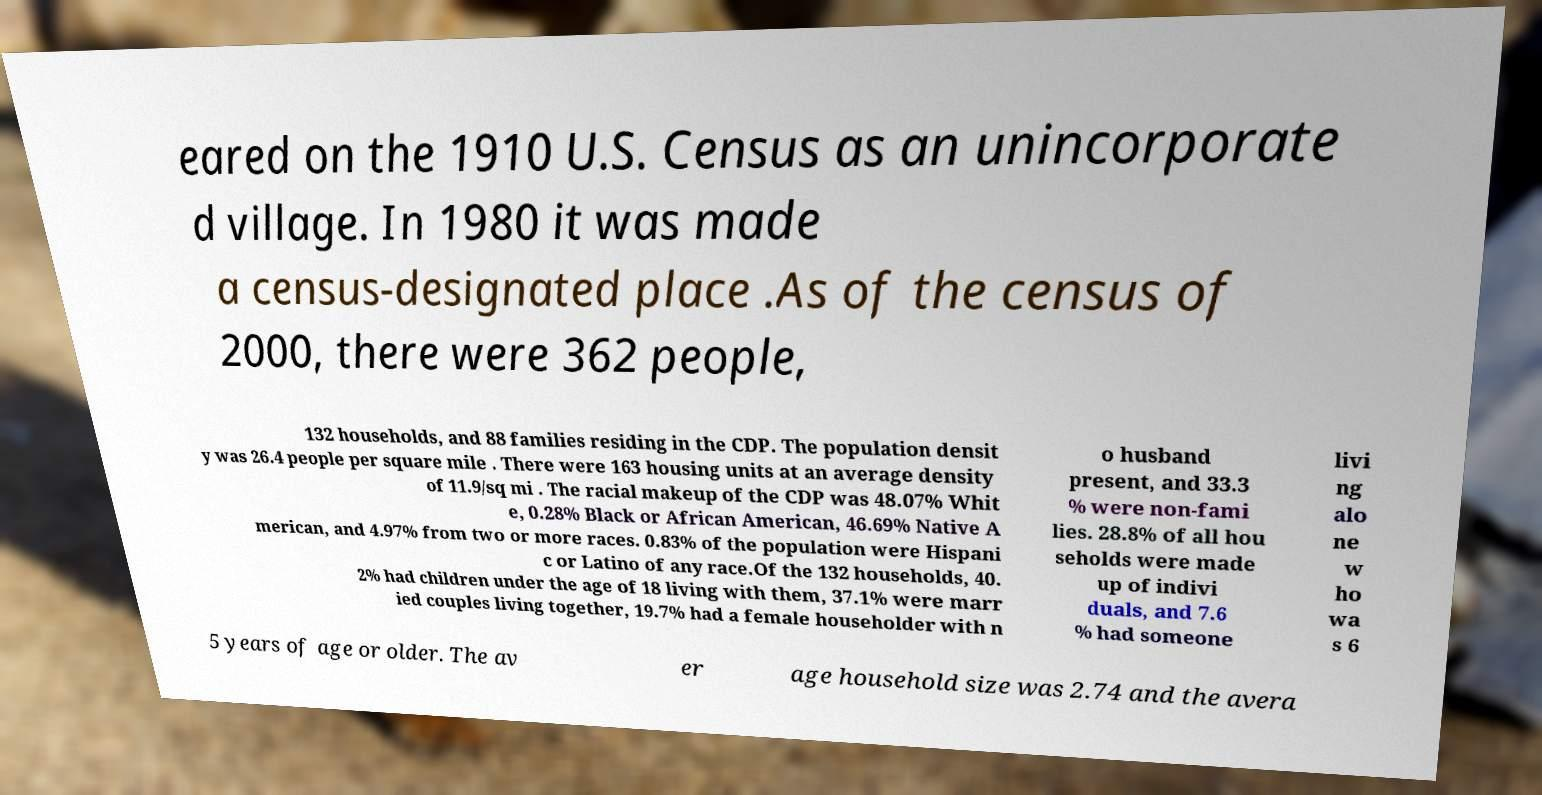What messages or text are displayed in this image? I need them in a readable, typed format. eared on the 1910 U.S. Census as an unincorporate d village. In 1980 it was made a census-designated place .As of the census of 2000, there were 362 people, 132 households, and 88 families residing in the CDP. The population densit y was 26.4 people per square mile . There were 163 housing units at an average density of 11.9/sq mi . The racial makeup of the CDP was 48.07% Whit e, 0.28% Black or African American, 46.69% Native A merican, and 4.97% from two or more races. 0.83% of the population were Hispani c or Latino of any race.Of the 132 households, 40. 2% had children under the age of 18 living with them, 37.1% were marr ied couples living together, 19.7% had a female householder with n o husband present, and 33.3 % were non-fami lies. 28.8% of all hou seholds were made up of indivi duals, and 7.6 % had someone livi ng alo ne w ho wa s 6 5 years of age or older. The av er age household size was 2.74 and the avera 